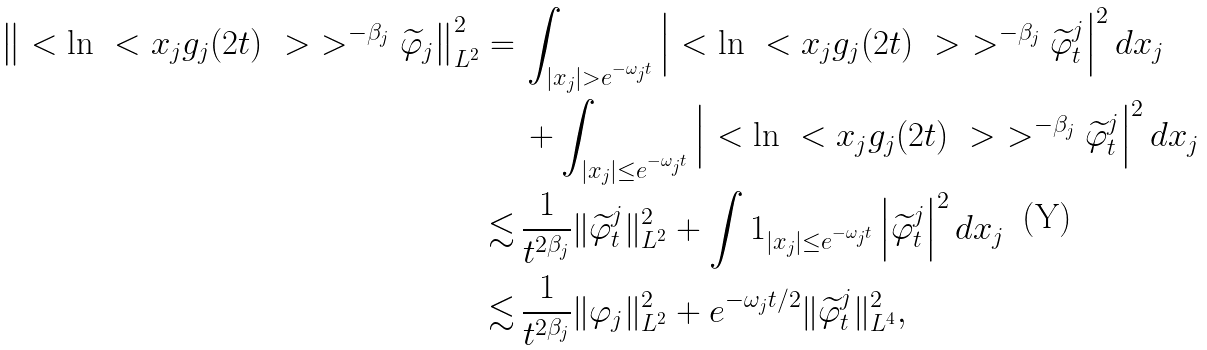<formula> <loc_0><loc_0><loc_500><loc_500>\left \| \ < \ln \ < x _ { j } g _ { j } ( 2 t ) \ > \ > ^ { - \beta _ { j } } \widetilde { \varphi } _ { j } \right \| _ { L ^ { 2 } } ^ { 2 } = \, & \int _ { | x _ { j } | > e ^ { - \omega _ { j } t } } \left | \ < \ln \ < x _ { j } g _ { j } ( 2 t ) \ > \ > ^ { - \beta _ { j } } \widetilde { \varphi } ^ { j } _ { t } \right | ^ { 2 } d x _ { j } \\ & + \int _ { | x _ { j } | \leq e ^ { - \omega _ { j } t } } \left | \ < \ln \ < x _ { j } g _ { j } ( 2 t ) \ > \ > ^ { - \beta _ { j } } \widetilde { \varphi } ^ { j } _ { t } \right | ^ { 2 } d x _ { j } \\ \lesssim \, & \frac { 1 } { t ^ { 2 \beta _ { j } } } \| \widetilde { \varphi } ^ { j } _ { t } \| _ { L ^ { 2 } } ^ { 2 } + \int { 1 } _ { | x _ { j } | \leq e ^ { - \omega _ { j } t } } \left | \widetilde { \varphi } ^ { j } _ { t } \right | ^ { 2 } d x _ { j } \\ \lesssim \, & \frac { 1 } { t ^ { 2 \beta _ { j } } } \| \varphi _ { j } \| _ { L ^ { 2 } } ^ { 2 } + e ^ { - \omega _ { j } t / 2 } \| \widetilde { \varphi } ^ { j } _ { t } \| _ { L ^ { 4 } } ^ { 2 } ,</formula> 